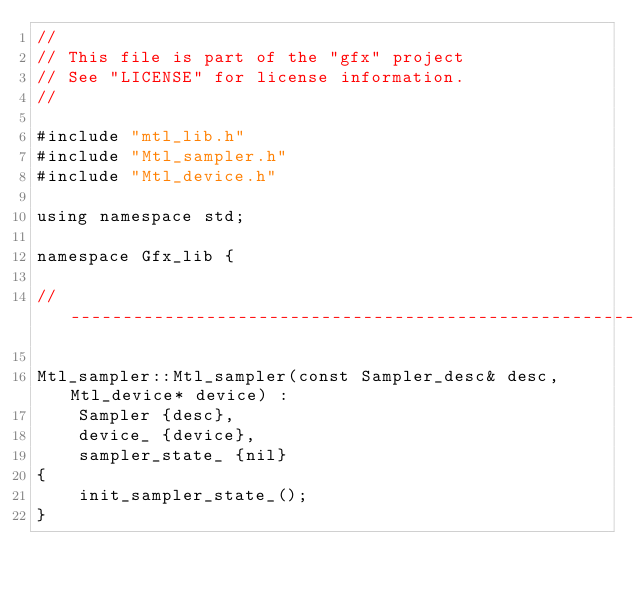<code> <loc_0><loc_0><loc_500><loc_500><_ObjectiveC_>//
// This file is part of the "gfx" project
// See "LICENSE" for license information.
//

#include "mtl_lib.h"
#include "Mtl_sampler.h"
#include "Mtl_device.h"

using namespace std;

namespace Gfx_lib {

//----------------------------------------------------------------------------------------------------------------------

Mtl_sampler::Mtl_sampler(const Sampler_desc& desc, Mtl_device* device) :
    Sampler {desc},
    device_ {device},
    sampler_state_ {nil}
{
    init_sampler_state_();
}
</code> 